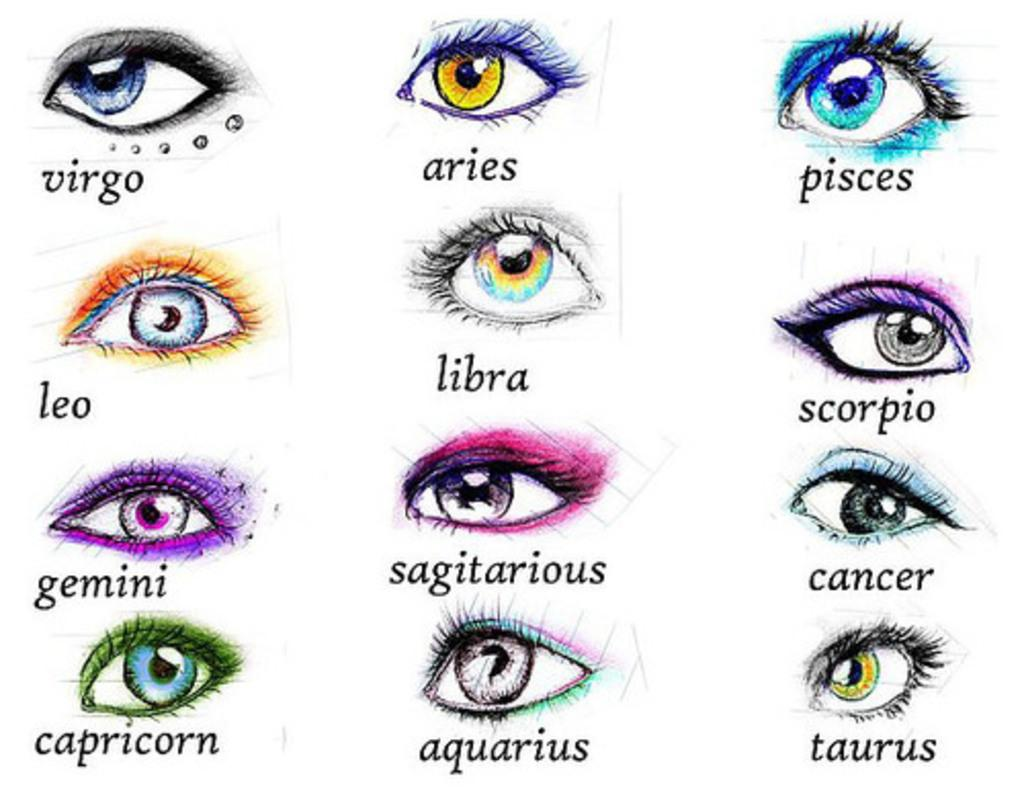What can be found in the image that conveys information or ideas? There is text in the image that conveys information or ideas. What type of images are present in the image? There are pictures of eyes in the image. What is the reaction of the governor to the low tide in the image? There is no governor or low tide present in the image; it only contains text and pictures of eyes. 